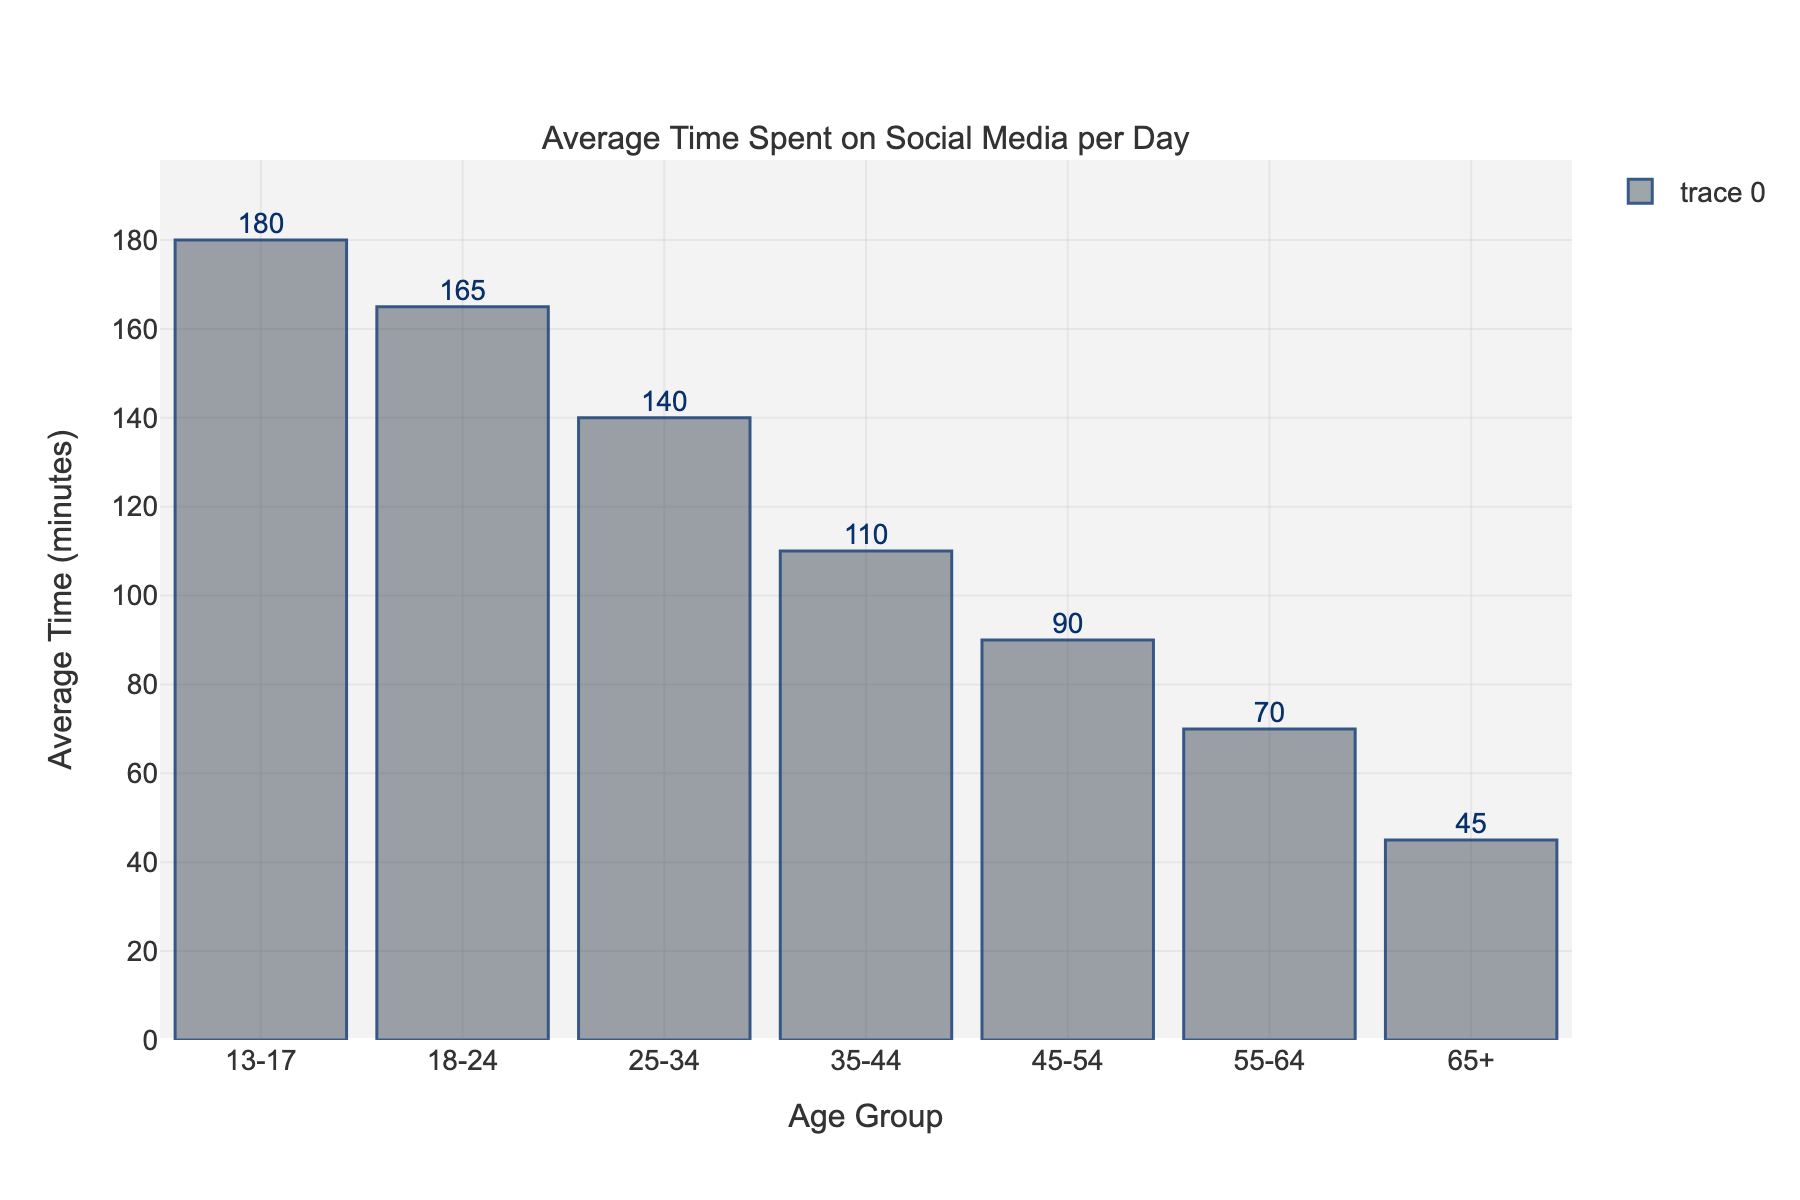Which age group spends the most time on social media per day? The tallest bar represents the age group 13-17, indicating it has the highest average time spent on social media per day.
Answer: 13-17 Which age group spends the least time on social media per day? The shortest bar represents the age group 65+, indicating it has the lowest average time spent on social media per day.
Answer: 65+ What is the difference in the average time spent on social media between the 13-17 and 65+ age groups? The 13-17 age group spends 180 minutes, and the 65+ age group spends 45 minutes. The difference is 180 - 45 = 135 minutes.
Answer: 135 minutes Which age group shows a noticeable drop in average time spent compared to the previous younger age group? The difference between the average times spent for the age groups 18-24 (165 minutes) and 13-17 (180 minutes) is smaller compared to the difference between other consecutive age groups. So 35-44 and 45-54 (110 and 90 minutes respectively) show the first noticeable bigger drop.
Answer: 35-44 and 45-54 Calculate the average time spent on social media for all age groups combined. Sum the times (180 + 165 + 140 + 110 + 90 + 70 + 45) = 800 minutes. There are 7 age groups, so the average is 800 / 7 ≈ 114.3 minutes.
Answer: ≈ 114.3 minutes What is the total range of average time spent on social media across all age groups? The highest average time is 180 minutes for the 13-17 age group, and the lowest is 45 minutes for the 65+ age group. The range is 180 - 45 = 135 minutes.
Answer: 135 minutes How much more time do the 25-34 age group spend on social media compared to the 45-54 age group? The 25-34 age group spends 140 minutes, and the 45-54 age group spends 90 minutes. The difference is 140 - 90 = 50 minutes.
Answer: 50 minutes Which two consecutive age groups have the smallest difference in average time spent on social media? Comparing consecutive age groups, the smallest difference is between 13-17 (180 minutes) and 18-24 (165 minutes), with a difference of 15 minutes.
Answer: 13-17 and 18-24 If combining the 35-44 and 45-54 age groups, what would be their new average time spent on social media? Sum the times (110 + 90) = 200 minutes. There are 2 age groups, so the average is 200 / 2 = 100 minutes.
Answer: 100 minutes How does the 55-64 age group's social media usage compare to the average of all age groups? The 55-64 age group spends 70 minutes. The average of all age groups is approximately 114.3 minutes. 70 is less than 114.3.
Answer: Less than the average 